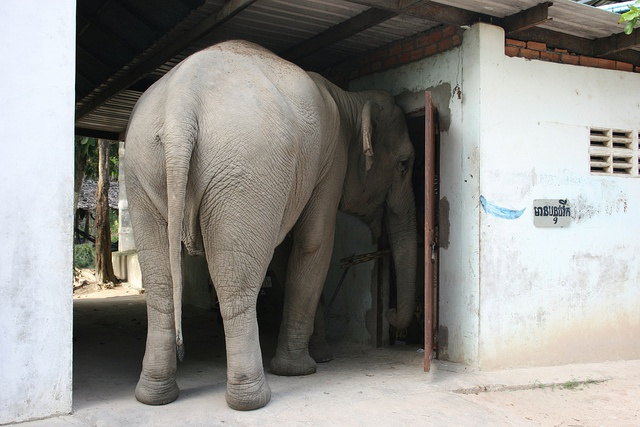Describe the objects in this image and their specific colors. I can see a elephant in lavender, darkgray, black, and gray tones in this image. 